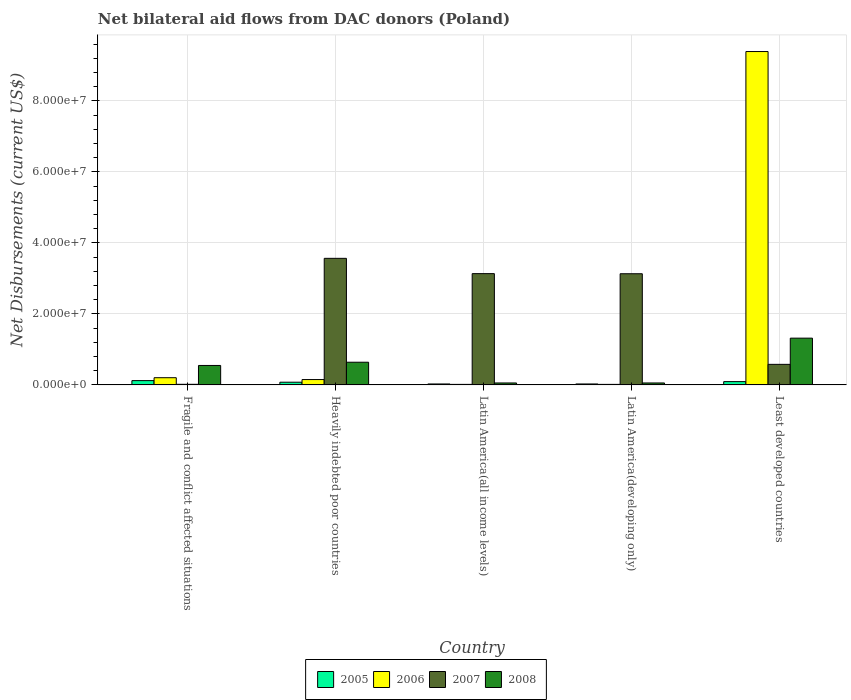How many different coloured bars are there?
Offer a very short reply. 4. How many groups of bars are there?
Provide a short and direct response. 5. Are the number of bars per tick equal to the number of legend labels?
Your response must be concise. Yes. Are the number of bars on each tick of the X-axis equal?
Provide a succinct answer. Yes. How many bars are there on the 3rd tick from the left?
Keep it short and to the point. 4. How many bars are there on the 1st tick from the right?
Provide a succinct answer. 4. What is the label of the 5th group of bars from the left?
Your response must be concise. Least developed countries. In how many cases, is the number of bars for a given country not equal to the number of legend labels?
Give a very brief answer. 0. What is the net bilateral aid flows in 2005 in Heavily indebted poor countries?
Provide a succinct answer. 7.60e+05. Across all countries, what is the maximum net bilateral aid flows in 2008?
Keep it short and to the point. 1.32e+07. In which country was the net bilateral aid flows in 2006 maximum?
Your answer should be compact. Least developed countries. In which country was the net bilateral aid flows in 2007 minimum?
Offer a terse response. Fragile and conflict affected situations. What is the total net bilateral aid flows in 2005 in the graph?
Provide a succinct answer. 3.44e+06. What is the difference between the net bilateral aid flows in 2008 in Heavily indebted poor countries and that in Least developed countries?
Your response must be concise. -6.78e+06. What is the difference between the net bilateral aid flows in 2008 in Latin America(developing only) and the net bilateral aid flows in 2005 in Least developed countries?
Offer a terse response. -3.80e+05. What is the average net bilateral aid flows in 2008 per country?
Your answer should be very brief. 5.23e+06. What is the difference between the net bilateral aid flows of/in 2006 and net bilateral aid flows of/in 2008 in Fragile and conflict affected situations?
Provide a short and direct response. -3.45e+06. In how many countries, is the net bilateral aid flows in 2007 greater than 92000000 US$?
Offer a terse response. 0. What is the ratio of the net bilateral aid flows in 2006 in Heavily indebted poor countries to that in Latin America(developing only)?
Your answer should be very brief. 10.07. Is the net bilateral aid flows in 2006 in Heavily indebted poor countries less than that in Least developed countries?
Offer a terse response. Yes. Is the difference between the net bilateral aid flows in 2006 in Latin America(all income levels) and Least developed countries greater than the difference between the net bilateral aid flows in 2008 in Latin America(all income levels) and Least developed countries?
Ensure brevity in your answer.  No. What is the difference between the highest and the second highest net bilateral aid flows in 2007?
Your answer should be very brief. 4.31e+06. What is the difference between the highest and the lowest net bilateral aid flows in 2005?
Provide a succinct answer. 9.40e+05. In how many countries, is the net bilateral aid flows in 2005 greater than the average net bilateral aid flows in 2005 taken over all countries?
Offer a terse response. 3. What does the 3rd bar from the left in Latin America(all income levels) represents?
Provide a short and direct response. 2007. What does the 3rd bar from the right in Latin America(developing only) represents?
Provide a short and direct response. 2006. Is it the case that in every country, the sum of the net bilateral aid flows in 2005 and net bilateral aid flows in 2008 is greater than the net bilateral aid flows in 2007?
Your answer should be compact. No. How many bars are there?
Provide a short and direct response. 20. Are all the bars in the graph horizontal?
Offer a terse response. No. Does the graph contain any zero values?
Provide a succinct answer. No. Does the graph contain grids?
Give a very brief answer. Yes. How many legend labels are there?
Your answer should be very brief. 4. How are the legend labels stacked?
Your response must be concise. Horizontal. What is the title of the graph?
Keep it short and to the point. Net bilateral aid flows from DAC donors (Poland). Does "1965" appear as one of the legend labels in the graph?
Your response must be concise. No. What is the label or title of the X-axis?
Provide a short and direct response. Country. What is the label or title of the Y-axis?
Ensure brevity in your answer.  Net Disbursements (current US$). What is the Net Disbursements (current US$) in 2005 in Fragile and conflict affected situations?
Provide a succinct answer. 1.21e+06. What is the Net Disbursements (current US$) in 2006 in Fragile and conflict affected situations?
Make the answer very short. 2.03e+06. What is the Net Disbursements (current US$) in 2008 in Fragile and conflict affected situations?
Give a very brief answer. 5.48e+06. What is the Net Disbursements (current US$) of 2005 in Heavily indebted poor countries?
Offer a terse response. 7.60e+05. What is the Net Disbursements (current US$) in 2006 in Heavily indebted poor countries?
Your answer should be very brief. 1.51e+06. What is the Net Disbursements (current US$) in 2007 in Heavily indebted poor countries?
Keep it short and to the point. 3.56e+07. What is the Net Disbursements (current US$) of 2008 in Heavily indebted poor countries?
Ensure brevity in your answer.  6.39e+06. What is the Net Disbursements (current US$) in 2007 in Latin America(all income levels)?
Offer a very short reply. 3.13e+07. What is the Net Disbursements (current US$) of 2007 in Latin America(developing only)?
Offer a terse response. 3.13e+07. What is the Net Disbursements (current US$) in 2005 in Least developed countries?
Ensure brevity in your answer.  9.30e+05. What is the Net Disbursements (current US$) of 2006 in Least developed countries?
Provide a succinct answer. 9.39e+07. What is the Net Disbursements (current US$) of 2007 in Least developed countries?
Offer a very short reply. 5.79e+06. What is the Net Disbursements (current US$) in 2008 in Least developed countries?
Your response must be concise. 1.32e+07. Across all countries, what is the maximum Net Disbursements (current US$) in 2005?
Ensure brevity in your answer.  1.21e+06. Across all countries, what is the maximum Net Disbursements (current US$) in 2006?
Your answer should be very brief. 9.39e+07. Across all countries, what is the maximum Net Disbursements (current US$) in 2007?
Your response must be concise. 3.56e+07. Across all countries, what is the maximum Net Disbursements (current US$) in 2008?
Give a very brief answer. 1.32e+07. Across all countries, what is the minimum Net Disbursements (current US$) in 2005?
Give a very brief answer. 2.70e+05. Across all countries, what is the minimum Net Disbursements (current US$) in 2007?
Your response must be concise. 1.70e+05. What is the total Net Disbursements (current US$) of 2005 in the graph?
Offer a terse response. 3.44e+06. What is the total Net Disbursements (current US$) in 2006 in the graph?
Offer a terse response. 9.77e+07. What is the total Net Disbursements (current US$) in 2007 in the graph?
Make the answer very short. 1.04e+08. What is the total Net Disbursements (current US$) in 2008 in the graph?
Make the answer very short. 2.61e+07. What is the difference between the Net Disbursements (current US$) of 2006 in Fragile and conflict affected situations and that in Heavily indebted poor countries?
Provide a short and direct response. 5.20e+05. What is the difference between the Net Disbursements (current US$) in 2007 in Fragile and conflict affected situations and that in Heavily indebted poor countries?
Make the answer very short. -3.55e+07. What is the difference between the Net Disbursements (current US$) of 2008 in Fragile and conflict affected situations and that in Heavily indebted poor countries?
Provide a short and direct response. -9.10e+05. What is the difference between the Net Disbursements (current US$) of 2005 in Fragile and conflict affected situations and that in Latin America(all income levels)?
Give a very brief answer. 9.40e+05. What is the difference between the Net Disbursements (current US$) in 2006 in Fragile and conflict affected situations and that in Latin America(all income levels)?
Make the answer very short. 1.88e+06. What is the difference between the Net Disbursements (current US$) of 2007 in Fragile and conflict affected situations and that in Latin America(all income levels)?
Give a very brief answer. -3.12e+07. What is the difference between the Net Disbursements (current US$) of 2008 in Fragile and conflict affected situations and that in Latin America(all income levels)?
Provide a succinct answer. 4.93e+06. What is the difference between the Net Disbursements (current US$) in 2005 in Fragile and conflict affected situations and that in Latin America(developing only)?
Provide a short and direct response. 9.40e+05. What is the difference between the Net Disbursements (current US$) of 2006 in Fragile and conflict affected situations and that in Latin America(developing only)?
Provide a short and direct response. 1.88e+06. What is the difference between the Net Disbursements (current US$) of 2007 in Fragile and conflict affected situations and that in Latin America(developing only)?
Offer a terse response. -3.11e+07. What is the difference between the Net Disbursements (current US$) in 2008 in Fragile and conflict affected situations and that in Latin America(developing only)?
Ensure brevity in your answer.  4.93e+06. What is the difference between the Net Disbursements (current US$) in 2006 in Fragile and conflict affected situations and that in Least developed countries?
Your answer should be very brief. -9.19e+07. What is the difference between the Net Disbursements (current US$) of 2007 in Fragile and conflict affected situations and that in Least developed countries?
Provide a succinct answer. -5.62e+06. What is the difference between the Net Disbursements (current US$) of 2008 in Fragile and conflict affected situations and that in Least developed countries?
Your answer should be very brief. -7.69e+06. What is the difference between the Net Disbursements (current US$) in 2005 in Heavily indebted poor countries and that in Latin America(all income levels)?
Offer a very short reply. 4.90e+05. What is the difference between the Net Disbursements (current US$) of 2006 in Heavily indebted poor countries and that in Latin America(all income levels)?
Offer a very short reply. 1.36e+06. What is the difference between the Net Disbursements (current US$) in 2007 in Heavily indebted poor countries and that in Latin America(all income levels)?
Your response must be concise. 4.31e+06. What is the difference between the Net Disbursements (current US$) of 2008 in Heavily indebted poor countries and that in Latin America(all income levels)?
Keep it short and to the point. 5.84e+06. What is the difference between the Net Disbursements (current US$) of 2006 in Heavily indebted poor countries and that in Latin America(developing only)?
Your answer should be very brief. 1.36e+06. What is the difference between the Net Disbursements (current US$) in 2007 in Heavily indebted poor countries and that in Latin America(developing only)?
Provide a succinct answer. 4.34e+06. What is the difference between the Net Disbursements (current US$) of 2008 in Heavily indebted poor countries and that in Latin America(developing only)?
Keep it short and to the point. 5.84e+06. What is the difference between the Net Disbursements (current US$) in 2005 in Heavily indebted poor countries and that in Least developed countries?
Give a very brief answer. -1.70e+05. What is the difference between the Net Disbursements (current US$) of 2006 in Heavily indebted poor countries and that in Least developed countries?
Your answer should be compact. -9.24e+07. What is the difference between the Net Disbursements (current US$) of 2007 in Heavily indebted poor countries and that in Least developed countries?
Provide a succinct answer. 2.99e+07. What is the difference between the Net Disbursements (current US$) of 2008 in Heavily indebted poor countries and that in Least developed countries?
Your answer should be compact. -6.78e+06. What is the difference between the Net Disbursements (current US$) in 2007 in Latin America(all income levels) and that in Latin America(developing only)?
Your answer should be compact. 3.00e+04. What is the difference between the Net Disbursements (current US$) in 2008 in Latin America(all income levels) and that in Latin America(developing only)?
Provide a succinct answer. 0. What is the difference between the Net Disbursements (current US$) in 2005 in Latin America(all income levels) and that in Least developed countries?
Provide a short and direct response. -6.60e+05. What is the difference between the Net Disbursements (current US$) in 2006 in Latin America(all income levels) and that in Least developed countries?
Ensure brevity in your answer.  -9.37e+07. What is the difference between the Net Disbursements (current US$) of 2007 in Latin America(all income levels) and that in Least developed countries?
Provide a succinct answer. 2.56e+07. What is the difference between the Net Disbursements (current US$) in 2008 in Latin America(all income levels) and that in Least developed countries?
Make the answer very short. -1.26e+07. What is the difference between the Net Disbursements (current US$) of 2005 in Latin America(developing only) and that in Least developed countries?
Your answer should be compact. -6.60e+05. What is the difference between the Net Disbursements (current US$) of 2006 in Latin America(developing only) and that in Least developed countries?
Give a very brief answer. -9.37e+07. What is the difference between the Net Disbursements (current US$) of 2007 in Latin America(developing only) and that in Least developed countries?
Offer a very short reply. 2.55e+07. What is the difference between the Net Disbursements (current US$) of 2008 in Latin America(developing only) and that in Least developed countries?
Your answer should be compact. -1.26e+07. What is the difference between the Net Disbursements (current US$) in 2005 in Fragile and conflict affected situations and the Net Disbursements (current US$) in 2006 in Heavily indebted poor countries?
Provide a short and direct response. -3.00e+05. What is the difference between the Net Disbursements (current US$) of 2005 in Fragile and conflict affected situations and the Net Disbursements (current US$) of 2007 in Heavily indebted poor countries?
Offer a terse response. -3.44e+07. What is the difference between the Net Disbursements (current US$) of 2005 in Fragile and conflict affected situations and the Net Disbursements (current US$) of 2008 in Heavily indebted poor countries?
Ensure brevity in your answer.  -5.18e+06. What is the difference between the Net Disbursements (current US$) in 2006 in Fragile and conflict affected situations and the Net Disbursements (current US$) in 2007 in Heavily indebted poor countries?
Ensure brevity in your answer.  -3.36e+07. What is the difference between the Net Disbursements (current US$) in 2006 in Fragile and conflict affected situations and the Net Disbursements (current US$) in 2008 in Heavily indebted poor countries?
Ensure brevity in your answer.  -4.36e+06. What is the difference between the Net Disbursements (current US$) of 2007 in Fragile and conflict affected situations and the Net Disbursements (current US$) of 2008 in Heavily indebted poor countries?
Ensure brevity in your answer.  -6.22e+06. What is the difference between the Net Disbursements (current US$) of 2005 in Fragile and conflict affected situations and the Net Disbursements (current US$) of 2006 in Latin America(all income levels)?
Offer a terse response. 1.06e+06. What is the difference between the Net Disbursements (current US$) in 2005 in Fragile and conflict affected situations and the Net Disbursements (current US$) in 2007 in Latin America(all income levels)?
Provide a short and direct response. -3.01e+07. What is the difference between the Net Disbursements (current US$) of 2006 in Fragile and conflict affected situations and the Net Disbursements (current US$) of 2007 in Latin America(all income levels)?
Offer a very short reply. -2.93e+07. What is the difference between the Net Disbursements (current US$) of 2006 in Fragile and conflict affected situations and the Net Disbursements (current US$) of 2008 in Latin America(all income levels)?
Provide a short and direct response. 1.48e+06. What is the difference between the Net Disbursements (current US$) of 2007 in Fragile and conflict affected situations and the Net Disbursements (current US$) of 2008 in Latin America(all income levels)?
Ensure brevity in your answer.  -3.80e+05. What is the difference between the Net Disbursements (current US$) of 2005 in Fragile and conflict affected situations and the Net Disbursements (current US$) of 2006 in Latin America(developing only)?
Your answer should be very brief. 1.06e+06. What is the difference between the Net Disbursements (current US$) in 2005 in Fragile and conflict affected situations and the Net Disbursements (current US$) in 2007 in Latin America(developing only)?
Keep it short and to the point. -3.01e+07. What is the difference between the Net Disbursements (current US$) of 2006 in Fragile and conflict affected situations and the Net Disbursements (current US$) of 2007 in Latin America(developing only)?
Your answer should be very brief. -2.93e+07. What is the difference between the Net Disbursements (current US$) in 2006 in Fragile and conflict affected situations and the Net Disbursements (current US$) in 2008 in Latin America(developing only)?
Your answer should be very brief. 1.48e+06. What is the difference between the Net Disbursements (current US$) of 2007 in Fragile and conflict affected situations and the Net Disbursements (current US$) of 2008 in Latin America(developing only)?
Keep it short and to the point. -3.80e+05. What is the difference between the Net Disbursements (current US$) of 2005 in Fragile and conflict affected situations and the Net Disbursements (current US$) of 2006 in Least developed countries?
Provide a short and direct response. -9.27e+07. What is the difference between the Net Disbursements (current US$) in 2005 in Fragile and conflict affected situations and the Net Disbursements (current US$) in 2007 in Least developed countries?
Ensure brevity in your answer.  -4.58e+06. What is the difference between the Net Disbursements (current US$) in 2005 in Fragile and conflict affected situations and the Net Disbursements (current US$) in 2008 in Least developed countries?
Ensure brevity in your answer.  -1.20e+07. What is the difference between the Net Disbursements (current US$) of 2006 in Fragile and conflict affected situations and the Net Disbursements (current US$) of 2007 in Least developed countries?
Your response must be concise. -3.76e+06. What is the difference between the Net Disbursements (current US$) of 2006 in Fragile and conflict affected situations and the Net Disbursements (current US$) of 2008 in Least developed countries?
Give a very brief answer. -1.11e+07. What is the difference between the Net Disbursements (current US$) in 2007 in Fragile and conflict affected situations and the Net Disbursements (current US$) in 2008 in Least developed countries?
Your answer should be compact. -1.30e+07. What is the difference between the Net Disbursements (current US$) of 2005 in Heavily indebted poor countries and the Net Disbursements (current US$) of 2007 in Latin America(all income levels)?
Your response must be concise. -3.06e+07. What is the difference between the Net Disbursements (current US$) in 2005 in Heavily indebted poor countries and the Net Disbursements (current US$) in 2008 in Latin America(all income levels)?
Provide a succinct answer. 2.10e+05. What is the difference between the Net Disbursements (current US$) in 2006 in Heavily indebted poor countries and the Net Disbursements (current US$) in 2007 in Latin America(all income levels)?
Offer a terse response. -2.98e+07. What is the difference between the Net Disbursements (current US$) of 2006 in Heavily indebted poor countries and the Net Disbursements (current US$) of 2008 in Latin America(all income levels)?
Give a very brief answer. 9.60e+05. What is the difference between the Net Disbursements (current US$) in 2007 in Heavily indebted poor countries and the Net Disbursements (current US$) in 2008 in Latin America(all income levels)?
Provide a short and direct response. 3.51e+07. What is the difference between the Net Disbursements (current US$) in 2005 in Heavily indebted poor countries and the Net Disbursements (current US$) in 2006 in Latin America(developing only)?
Provide a succinct answer. 6.10e+05. What is the difference between the Net Disbursements (current US$) in 2005 in Heavily indebted poor countries and the Net Disbursements (current US$) in 2007 in Latin America(developing only)?
Offer a very short reply. -3.06e+07. What is the difference between the Net Disbursements (current US$) in 2005 in Heavily indebted poor countries and the Net Disbursements (current US$) in 2008 in Latin America(developing only)?
Ensure brevity in your answer.  2.10e+05. What is the difference between the Net Disbursements (current US$) in 2006 in Heavily indebted poor countries and the Net Disbursements (current US$) in 2007 in Latin America(developing only)?
Give a very brief answer. -2.98e+07. What is the difference between the Net Disbursements (current US$) in 2006 in Heavily indebted poor countries and the Net Disbursements (current US$) in 2008 in Latin America(developing only)?
Make the answer very short. 9.60e+05. What is the difference between the Net Disbursements (current US$) of 2007 in Heavily indebted poor countries and the Net Disbursements (current US$) of 2008 in Latin America(developing only)?
Provide a succinct answer. 3.51e+07. What is the difference between the Net Disbursements (current US$) of 2005 in Heavily indebted poor countries and the Net Disbursements (current US$) of 2006 in Least developed countries?
Your answer should be very brief. -9.31e+07. What is the difference between the Net Disbursements (current US$) of 2005 in Heavily indebted poor countries and the Net Disbursements (current US$) of 2007 in Least developed countries?
Provide a short and direct response. -5.03e+06. What is the difference between the Net Disbursements (current US$) in 2005 in Heavily indebted poor countries and the Net Disbursements (current US$) in 2008 in Least developed countries?
Provide a short and direct response. -1.24e+07. What is the difference between the Net Disbursements (current US$) of 2006 in Heavily indebted poor countries and the Net Disbursements (current US$) of 2007 in Least developed countries?
Make the answer very short. -4.28e+06. What is the difference between the Net Disbursements (current US$) in 2006 in Heavily indebted poor countries and the Net Disbursements (current US$) in 2008 in Least developed countries?
Give a very brief answer. -1.17e+07. What is the difference between the Net Disbursements (current US$) of 2007 in Heavily indebted poor countries and the Net Disbursements (current US$) of 2008 in Least developed countries?
Provide a short and direct response. 2.25e+07. What is the difference between the Net Disbursements (current US$) of 2005 in Latin America(all income levels) and the Net Disbursements (current US$) of 2007 in Latin America(developing only)?
Provide a short and direct response. -3.10e+07. What is the difference between the Net Disbursements (current US$) of 2005 in Latin America(all income levels) and the Net Disbursements (current US$) of 2008 in Latin America(developing only)?
Give a very brief answer. -2.80e+05. What is the difference between the Net Disbursements (current US$) in 2006 in Latin America(all income levels) and the Net Disbursements (current US$) in 2007 in Latin America(developing only)?
Make the answer very short. -3.12e+07. What is the difference between the Net Disbursements (current US$) in 2006 in Latin America(all income levels) and the Net Disbursements (current US$) in 2008 in Latin America(developing only)?
Provide a short and direct response. -4.00e+05. What is the difference between the Net Disbursements (current US$) in 2007 in Latin America(all income levels) and the Net Disbursements (current US$) in 2008 in Latin America(developing only)?
Make the answer very short. 3.08e+07. What is the difference between the Net Disbursements (current US$) of 2005 in Latin America(all income levels) and the Net Disbursements (current US$) of 2006 in Least developed countries?
Offer a terse response. -9.36e+07. What is the difference between the Net Disbursements (current US$) in 2005 in Latin America(all income levels) and the Net Disbursements (current US$) in 2007 in Least developed countries?
Offer a terse response. -5.52e+06. What is the difference between the Net Disbursements (current US$) in 2005 in Latin America(all income levels) and the Net Disbursements (current US$) in 2008 in Least developed countries?
Offer a terse response. -1.29e+07. What is the difference between the Net Disbursements (current US$) in 2006 in Latin America(all income levels) and the Net Disbursements (current US$) in 2007 in Least developed countries?
Provide a short and direct response. -5.64e+06. What is the difference between the Net Disbursements (current US$) of 2006 in Latin America(all income levels) and the Net Disbursements (current US$) of 2008 in Least developed countries?
Ensure brevity in your answer.  -1.30e+07. What is the difference between the Net Disbursements (current US$) of 2007 in Latin America(all income levels) and the Net Disbursements (current US$) of 2008 in Least developed countries?
Offer a terse response. 1.82e+07. What is the difference between the Net Disbursements (current US$) of 2005 in Latin America(developing only) and the Net Disbursements (current US$) of 2006 in Least developed countries?
Provide a short and direct response. -9.36e+07. What is the difference between the Net Disbursements (current US$) in 2005 in Latin America(developing only) and the Net Disbursements (current US$) in 2007 in Least developed countries?
Offer a very short reply. -5.52e+06. What is the difference between the Net Disbursements (current US$) in 2005 in Latin America(developing only) and the Net Disbursements (current US$) in 2008 in Least developed countries?
Ensure brevity in your answer.  -1.29e+07. What is the difference between the Net Disbursements (current US$) of 2006 in Latin America(developing only) and the Net Disbursements (current US$) of 2007 in Least developed countries?
Your answer should be very brief. -5.64e+06. What is the difference between the Net Disbursements (current US$) in 2006 in Latin America(developing only) and the Net Disbursements (current US$) in 2008 in Least developed countries?
Ensure brevity in your answer.  -1.30e+07. What is the difference between the Net Disbursements (current US$) of 2007 in Latin America(developing only) and the Net Disbursements (current US$) of 2008 in Least developed countries?
Make the answer very short. 1.81e+07. What is the average Net Disbursements (current US$) of 2005 per country?
Ensure brevity in your answer.  6.88e+05. What is the average Net Disbursements (current US$) in 2006 per country?
Offer a terse response. 1.95e+07. What is the average Net Disbursements (current US$) in 2007 per country?
Provide a short and direct response. 2.09e+07. What is the average Net Disbursements (current US$) in 2008 per country?
Your response must be concise. 5.23e+06. What is the difference between the Net Disbursements (current US$) of 2005 and Net Disbursements (current US$) of 2006 in Fragile and conflict affected situations?
Give a very brief answer. -8.20e+05. What is the difference between the Net Disbursements (current US$) of 2005 and Net Disbursements (current US$) of 2007 in Fragile and conflict affected situations?
Give a very brief answer. 1.04e+06. What is the difference between the Net Disbursements (current US$) of 2005 and Net Disbursements (current US$) of 2008 in Fragile and conflict affected situations?
Your answer should be very brief. -4.27e+06. What is the difference between the Net Disbursements (current US$) of 2006 and Net Disbursements (current US$) of 2007 in Fragile and conflict affected situations?
Your answer should be very brief. 1.86e+06. What is the difference between the Net Disbursements (current US$) in 2006 and Net Disbursements (current US$) in 2008 in Fragile and conflict affected situations?
Your answer should be compact. -3.45e+06. What is the difference between the Net Disbursements (current US$) of 2007 and Net Disbursements (current US$) of 2008 in Fragile and conflict affected situations?
Provide a short and direct response. -5.31e+06. What is the difference between the Net Disbursements (current US$) in 2005 and Net Disbursements (current US$) in 2006 in Heavily indebted poor countries?
Make the answer very short. -7.50e+05. What is the difference between the Net Disbursements (current US$) of 2005 and Net Disbursements (current US$) of 2007 in Heavily indebted poor countries?
Your response must be concise. -3.49e+07. What is the difference between the Net Disbursements (current US$) of 2005 and Net Disbursements (current US$) of 2008 in Heavily indebted poor countries?
Your answer should be compact. -5.63e+06. What is the difference between the Net Disbursements (current US$) of 2006 and Net Disbursements (current US$) of 2007 in Heavily indebted poor countries?
Keep it short and to the point. -3.41e+07. What is the difference between the Net Disbursements (current US$) in 2006 and Net Disbursements (current US$) in 2008 in Heavily indebted poor countries?
Give a very brief answer. -4.88e+06. What is the difference between the Net Disbursements (current US$) of 2007 and Net Disbursements (current US$) of 2008 in Heavily indebted poor countries?
Your answer should be compact. 2.93e+07. What is the difference between the Net Disbursements (current US$) of 2005 and Net Disbursements (current US$) of 2007 in Latin America(all income levels)?
Make the answer very short. -3.11e+07. What is the difference between the Net Disbursements (current US$) of 2005 and Net Disbursements (current US$) of 2008 in Latin America(all income levels)?
Give a very brief answer. -2.80e+05. What is the difference between the Net Disbursements (current US$) of 2006 and Net Disbursements (current US$) of 2007 in Latin America(all income levels)?
Ensure brevity in your answer.  -3.12e+07. What is the difference between the Net Disbursements (current US$) of 2006 and Net Disbursements (current US$) of 2008 in Latin America(all income levels)?
Your answer should be very brief. -4.00e+05. What is the difference between the Net Disbursements (current US$) of 2007 and Net Disbursements (current US$) of 2008 in Latin America(all income levels)?
Your response must be concise. 3.08e+07. What is the difference between the Net Disbursements (current US$) of 2005 and Net Disbursements (current US$) of 2006 in Latin America(developing only)?
Your answer should be very brief. 1.20e+05. What is the difference between the Net Disbursements (current US$) of 2005 and Net Disbursements (current US$) of 2007 in Latin America(developing only)?
Ensure brevity in your answer.  -3.10e+07. What is the difference between the Net Disbursements (current US$) of 2005 and Net Disbursements (current US$) of 2008 in Latin America(developing only)?
Your answer should be compact. -2.80e+05. What is the difference between the Net Disbursements (current US$) of 2006 and Net Disbursements (current US$) of 2007 in Latin America(developing only)?
Your response must be concise. -3.12e+07. What is the difference between the Net Disbursements (current US$) of 2006 and Net Disbursements (current US$) of 2008 in Latin America(developing only)?
Keep it short and to the point. -4.00e+05. What is the difference between the Net Disbursements (current US$) in 2007 and Net Disbursements (current US$) in 2008 in Latin America(developing only)?
Ensure brevity in your answer.  3.08e+07. What is the difference between the Net Disbursements (current US$) in 2005 and Net Disbursements (current US$) in 2006 in Least developed countries?
Keep it short and to the point. -9.30e+07. What is the difference between the Net Disbursements (current US$) of 2005 and Net Disbursements (current US$) of 2007 in Least developed countries?
Make the answer very short. -4.86e+06. What is the difference between the Net Disbursements (current US$) of 2005 and Net Disbursements (current US$) of 2008 in Least developed countries?
Provide a succinct answer. -1.22e+07. What is the difference between the Net Disbursements (current US$) of 2006 and Net Disbursements (current US$) of 2007 in Least developed countries?
Your answer should be compact. 8.81e+07. What is the difference between the Net Disbursements (current US$) in 2006 and Net Disbursements (current US$) in 2008 in Least developed countries?
Keep it short and to the point. 8.07e+07. What is the difference between the Net Disbursements (current US$) of 2007 and Net Disbursements (current US$) of 2008 in Least developed countries?
Give a very brief answer. -7.38e+06. What is the ratio of the Net Disbursements (current US$) of 2005 in Fragile and conflict affected situations to that in Heavily indebted poor countries?
Offer a terse response. 1.59. What is the ratio of the Net Disbursements (current US$) in 2006 in Fragile and conflict affected situations to that in Heavily indebted poor countries?
Your answer should be compact. 1.34. What is the ratio of the Net Disbursements (current US$) in 2007 in Fragile and conflict affected situations to that in Heavily indebted poor countries?
Your answer should be compact. 0. What is the ratio of the Net Disbursements (current US$) in 2008 in Fragile and conflict affected situations to that in Heavily indebted poor countries?
Make the answer very short. 0.86. What is the ratio of the Net Disbursements (current US$) in 2005 in Fragile and conflict affected situations to that in Latin America(all income levels)?
Provide a succinct answer. 4.48. What is the ratio of the Net Disbursements (current US$) of 2006 in Fragile and conflict affected situations to that in Latin America(all income levels)?
Provide a short and direct response. 13.53. What is the ratio of the Net Disbursements (current US$) in 2007 in Fragile and conflict affected situations to that in Latin America(all income levels)?
Give a very brief answer. 0.01. What is the ratio of the Net Disbursements (current US$) of 2008 in Fragile and conflict affected situations to that in Latin America(all income levels)?
Ensure brevity in your answer.  9.96. What is the ratio of the Net Disbursements (current US$) of 2005 in Fragile and conflict affected situations to that in Latin America(developing only)?
Offer a terse response. 4.48. What is the ratio of the Net Disbursements (current US$) of 2006 in Fragile and conflict affected situations to that in Latin America(developing only)?
Give a very brief answer. 13.53. What is the ratio of the Net Disbursements (current US$) in 2007 in Fragile and conflict affected situations to that in Latin America(developing only)?
Keep it short and to the point. 0.01. What is the ratio of the Net Disbursements (current US$) of 2008 in Fragile and conflict affected situations to that in Latin America(developing only)?
Make the answer very short. 9.96. What is the ratio of the Net Disbursements (current US$) of 2005 in Fragile and conflict affected situations to that in Least developed countries?
Make the answer very short. 1.3. What is the ratio of the Net Disbursements (current US$) of 2006 in Fragile and conflict affected situations to that in Least developed countries?
Give a very brief answer. 0.02. What is the ratio of the Net Disbursements (current US$) in 2007 in Fragile and conflict affected situations to that in Least developed countries?
Offer a very short reply. 0.03. What is the ratio of the Net Disbursements (current US$) of 2008 in Fragile and conflict affected situations to that in Least developed countries?
Provide a short and direct response. 0.42. What is the ratio of the Net Disbursements (current US$) in 2005 in Heavily indebted poor countries to that in Latin America(all income levels)?
Make the answer very short. 2.81. What is the ratio of the Net Disbursements (current US$) of 2006 in Heavily indebted poor countries to that in Latin America(all income levels)?
Give a very brief answer. 10.07. What is the ratio of the Net Disbursements (current US$) in 2007 in Heavily indebted poor countries to that in Latin America(all income levels)?
Make the answer very short. 1.14. What is the ratio of the Net Disbursements (current US$) of 2008 in Heavily indebted poor countries to that in Latin America(all income levels)?
Provide a succinct answer. 11.62. What is the ratio of the Net Disbursements (current US$) of 2005 in Heavily indebted poor countries to that in Latin America(developing only)?
Provide a short and direct response. 2.81. What is the ratio of the Net Disbursements (current US$) of 2006 in Heavily indebted poor countries to that in Latin America(developing only)?
Offer a terse response. 10.07. What is the ratio of the Net Disbursements (current US$) of 2007 in Heavily indebted poor countries to that in Latin America(developing only)?
Your answer should be very brief. 1.14. What is the ratio of the Net Disbursements (current US$) in 2008 in Heavily indebted poor countries to that in Latin America(developing only)?
Make the answer very short. 11.62. What is the ratio of the Net Disbursements (current US$) of 2005 in Heavily indebted poor countries to that in Least developed countries?
Offer a very short reply. 0.82. What is the ratio of the Net Disbursements (current US$) of 2006 in Heavily indebted poor countries to that in Least developed countries?
Make the answer very short. 0.02. What is the ratio of the Net Disbursements (current US$) in 2007 in Heavily indebted poor countries to that in Least developed countries?
Provide a short and direct response. 6.16. What is the ratio of the Net Disbursements (current US$) in 2008 in Heavily indebted poor countries to that in Least developed countries?
Offer a terse response. 0.49. What is the ratio of the Net Disbursements (current US$) of 2006 in Latin America(all income levels) to that in Latin America(developing only)?
Provide a succinct answer. 1. What is the ratio of the Net Disbursements (current US$) in 2007 in Latin America(all income levels) to that in Latin America(developing only)?
Offer a terse response. 1. What is the ratio of the Net Disbursements (current US$) in 2005 in Latin America(all income levels) to that in Least developed countries?
Make the answer very short. 0.29. What is the ratio of the Net Disbursements (current US$) of 2006 in Latin America(all income levels) to that in Least developed countries?
Keep it short and to the point. 0. What is the ratio of the Net Disbursements (current US$) of 2007 in Latin America(all income levels) to that in Least developed countries?
Your response must be concise. 5.41. What is the ratio of the Net Disbursements (current US$) of 2008 in Latin America(all income levels) to that in Least developed countries?
Your answer should be compact. 0.04. What is the ratio of the Net Disbursements (current US$) of 2005 in Latin America(developing only) to that in Least developed countries?
Offer a terse response. 0.29. What is the ratio of the Net Disbursements (current US$) of 2006 in Latin America(developing only) to that in Least developed countries?
Provide a short and direct response. 0. What is the ratio of the Net Disbursements (current US$) of 2007 in Latin America(developing only) to that in Least developed countries?
Make the answer very short. 5.41. What is the ratio of the Net Disbursements (current US$) in 2008 in Latin America(developing only) to that in Least developed countries?
Your answer should be very brief. 0.04. What is the difference between the highest and the second highest Net Disbursements (current US$) in 2005?
Your answer should be compact. 2.80e+05. What is the difference between the highest and the second highest Net Disbursements (current US$) in 2006?
Your response must be concise. 9.19e+07. What is the difference between the highest and the second highest Net Disbursements (current US$) in 2007?
Ensure brevity in your answer.  4.31e+06. What is the difference between the highest and the second highest Net Disbursements (current US$) of 2008?
Provide a short and direct response. 6.78e+06. What is the difference between the highest and the lowest Net Disbursements (current US$) of 2005?
Give a very brief answer. 9.40e+05. What is the difference between the highest and the lowest Net Disbursements (current US$) in 2006?
Ensure brevity in your answer.  9.37e+07. What is the difference between the highest and the lowest Net Disbursements (current US$) of 2007?
Ensure brevity in your answer.  3.55e+07. What is the difference between the highest and the lowest Net Disbursements (current US$) of 2008?
Keep it short and to the point. 1.26e+07. 